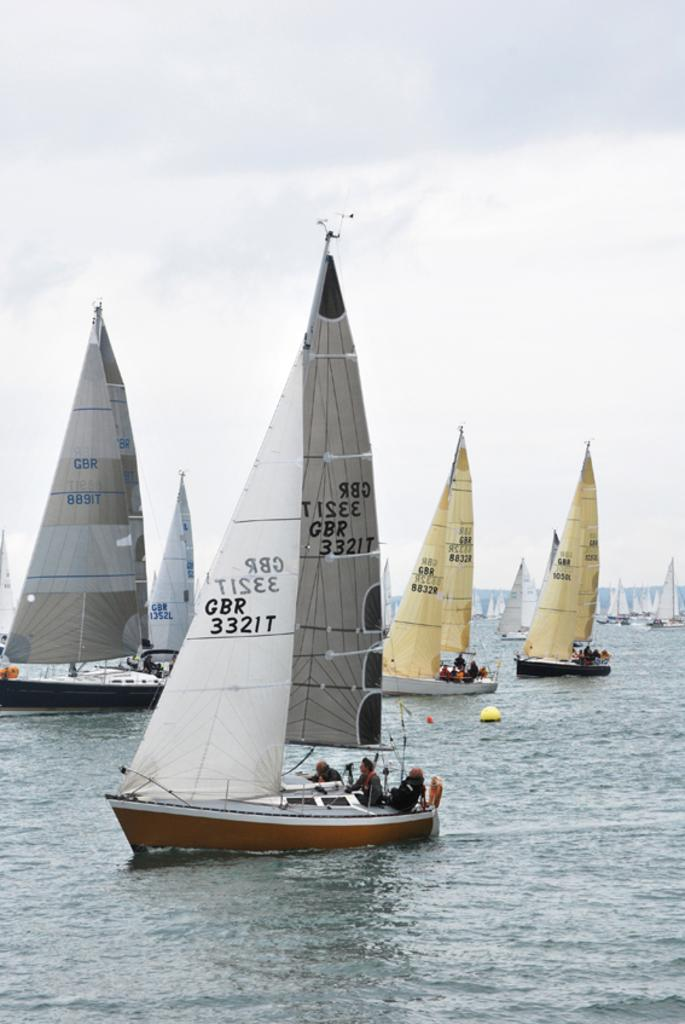Provide a one-sentence caption for the provided image. Many sailboats are in the water whose sails have GBR written on them. 